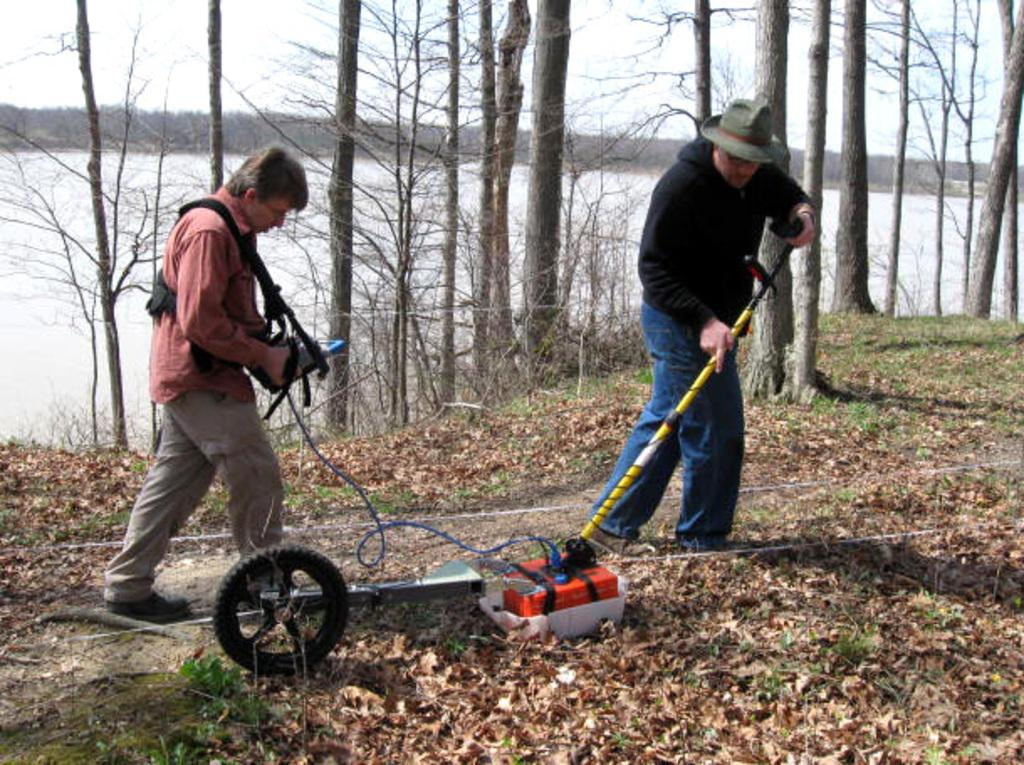What are the two people in the image doing? The two people are operating a device in the image. What can be seen at the bottom of the image? Dry leaves are present at the bottom of the image. What is visible in the background of the image? There are trees and the sky visible in the background of the image. Can you describe the natural environment in the image? The natural environment includes trees and water visible in the background of the image. What songs are the people singing while operating the device in the image? There is no indication in the image that the people are singing songs while operating the device. Can you see an apple in the image? There is no apple present in the image. 